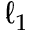<formula> <loc_0><loc_0><loc_500><loc_500>\ell _ { 1 }</formula> 